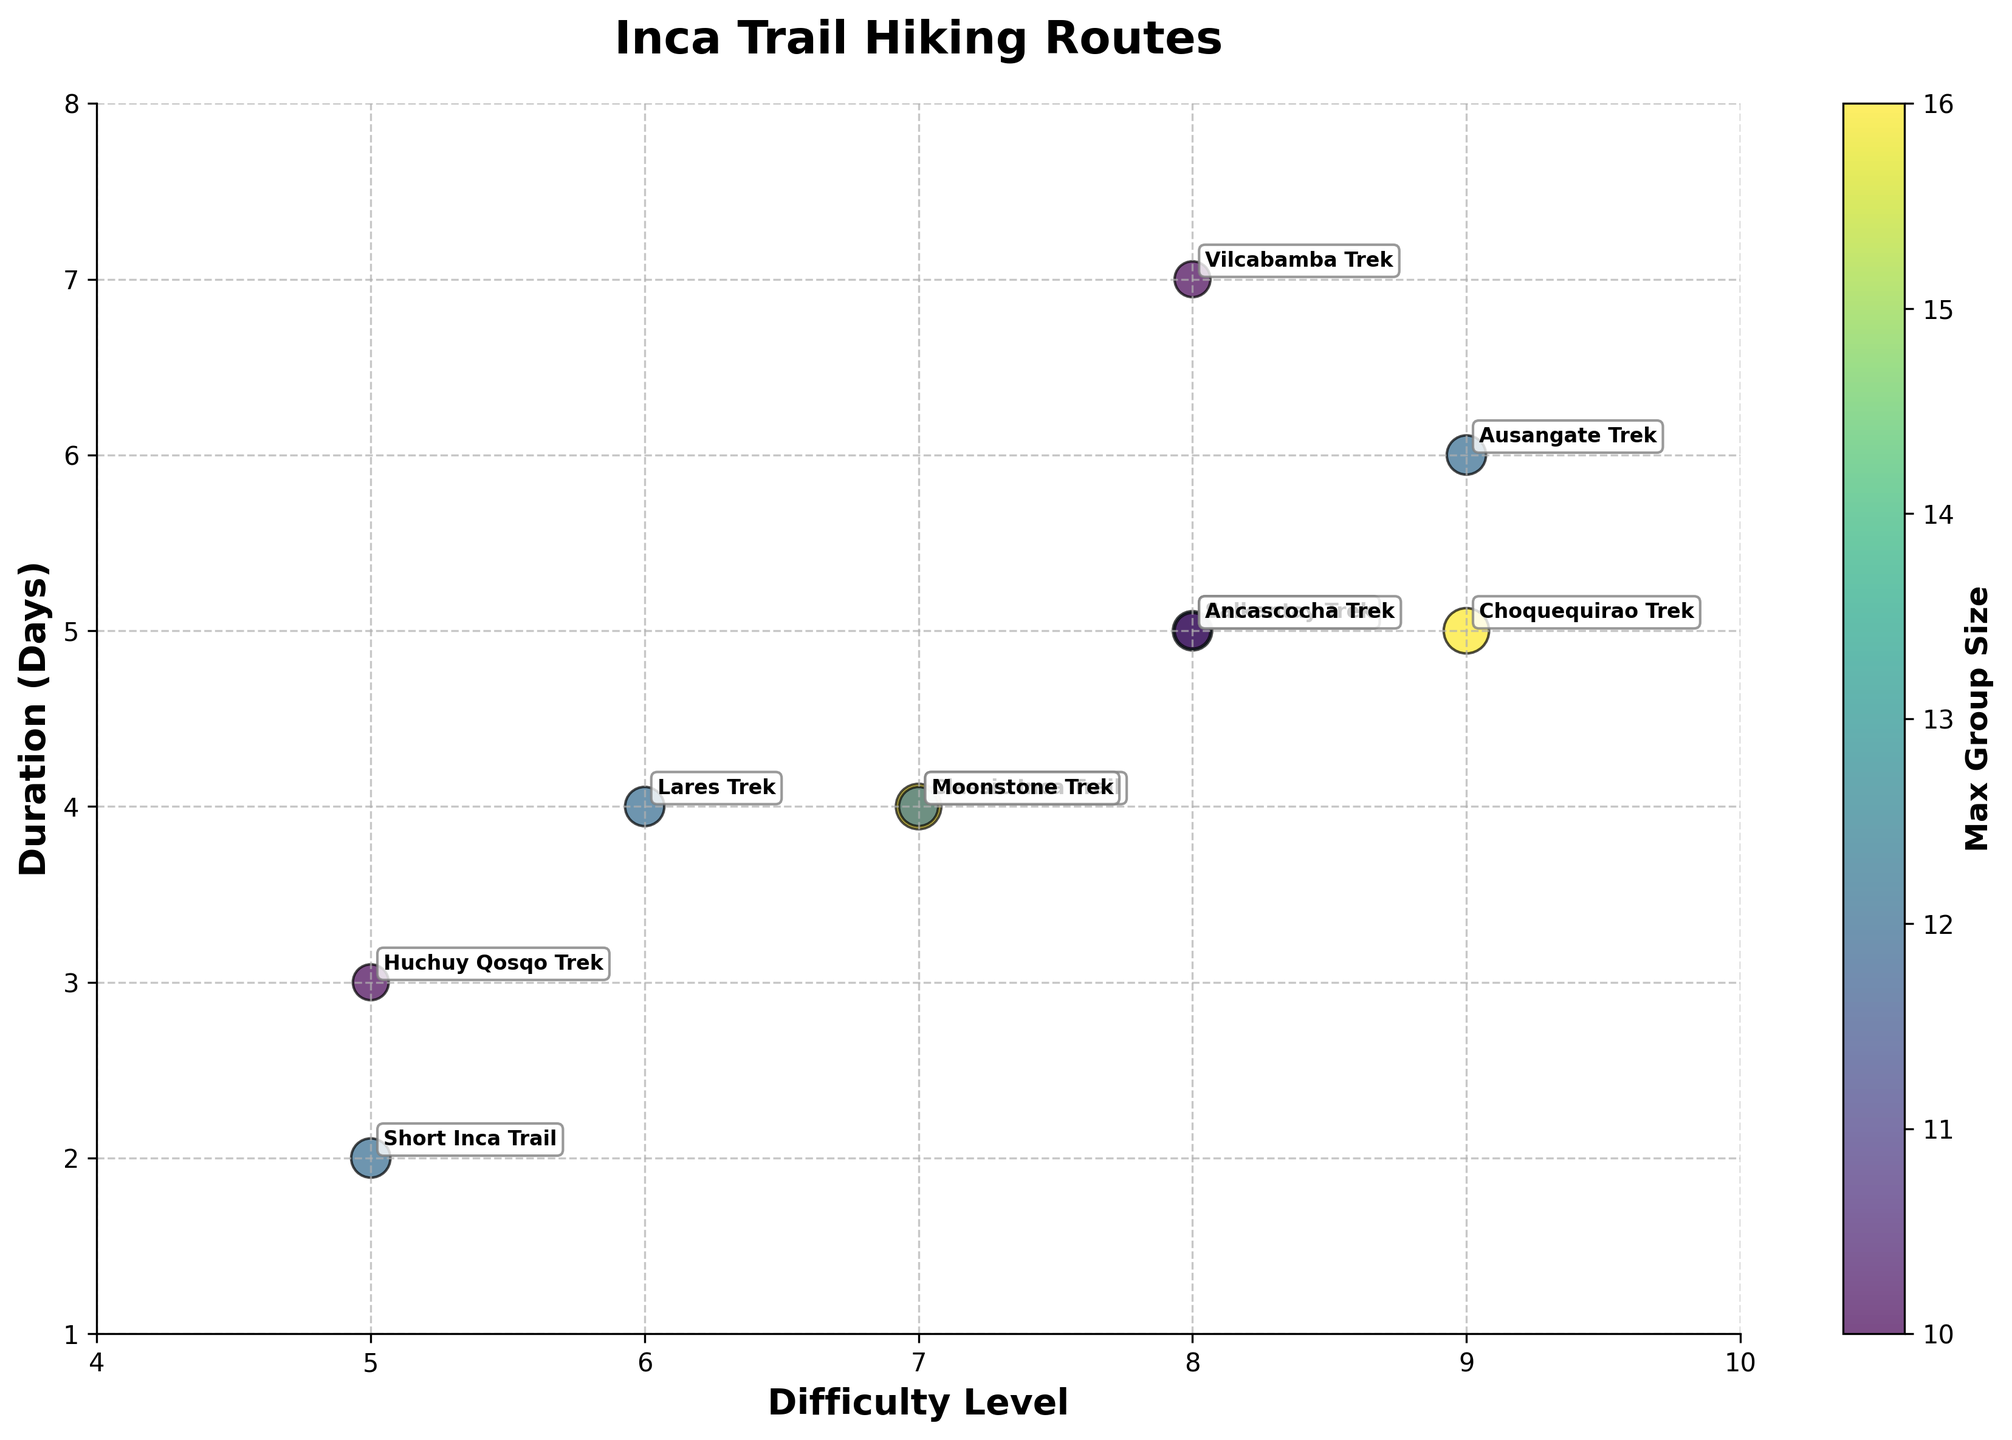What is the title of the figure? The title of a figure is typically located at the top and is set to give a brief description of the content or the purpose of the visual. In this case, the title is "Inca Trail Hiking Routes" as it is displayed prominently at the top of the figure.
Answer: Inca Trail Hiking Routes How many hiking routes are depicted in the figure? Count the number of bubbles, as each bubble represents a different hiking route. Based on the data provided, there are 10 routes mentioned in the figure.
Answer: 10 Which hiking route has the highest difficulty level? Look for the bubble positioned farthest to the right along the Difficulty Level axis. The Choquequirao Trek and Ausangate Trek have the highest difficulty level, which is 9.
Answer: Choquequirao Trek and Ausangate Trek What is the duration of the Short Inca Trail? Locate the bubble labeled "Short Inca Trail" and check its position along the Duration (Days) axis. This bubble is positioned at 2 on the Duration axis.
Answer: 2 days Which hiking route accommodates the largest group size? Look for the largest bubble on the plot, as size indicates group size. The largest bubbles in the plot are for the Classic Inca Trail and Choquequirao Trek, both accommodating a maximum group size of 16.
Answer: Classic Inca Trail and Choquequirao Trek What is the range of difficulty levels depicted in the figure? Identify the minimum and maximum values on the Difficulty Level axis. The difficulty levels range from 5 to 9 in this figure.
Answer: 5 to 9 What is the average duration of the hikes with a difficulty level of 8? Find all bubbles with a difficulty level of 8 and note their durations. The routes with difficulty level 8 are the Salkantay Trek, Vilcabamba Trek, and Ancascocha Trek with durations of 5, 7, and 5 days, respectively. Calculate the average by summing these values and dividing by the number of routes: (5 + 7 + 5) / 3 = 17 / 3 ≈ 5.67 days.
Answer: 5.67 days Which routes have a maximum group size of 12? Identify all bubbles with smaller sizes corresponding to a maximum group size of 12. These routes are the Short Inca Trail, Salkantay Trek, Lares Trek, Moonstone Trek, and Ausangate Trek.
Answer: Short Inca Trail, Salkantay Trek, Lares Trek, Moonstone Trek, and Ausangate Trek Which hiking route requires the longest duration? Find the bubble positioned highest on the Duration (Days) axis. The Vilcabamba Trek is located at the highest point with a duration of 7 days.
Answer: Vilcabamba Trek How does the difficulty of the Huchuy Qosqo Trek compare to the Ausangate Trek? Locate the bubbles for Huchuy Qosqo Trek and Ausangate Trek and compare their positions on the Difficulty Level axis. The Huchuy Qosqo Trek has a difficulty level of 5 while the Ausangate Trek has a difficulty level of 9.
Answer: Huchuy Qosqo Trek is less difficult than Ausangate Trek 